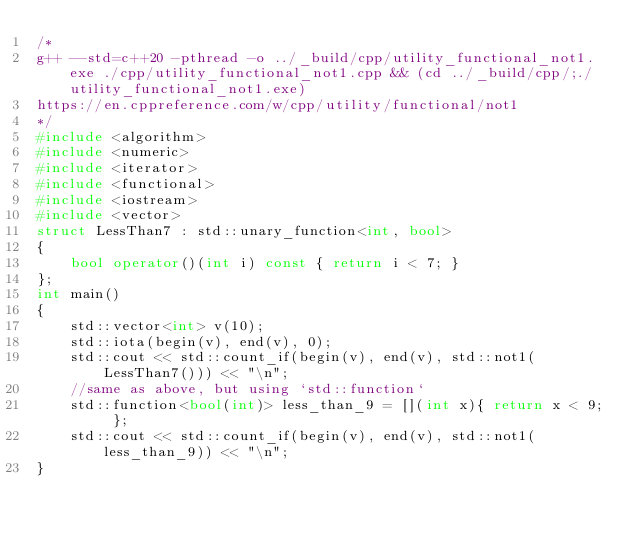<code> <loc_0><loc_0><loc_500><loc_500><_C++_>/*
g++ --std=c++20 -pthread -o ../_build/cpp/utility_functional_not1.exe ./cpp/utility_functional_not1.cpp && (cd ../_build/cpp/;./utility_functional_not1.exe)
https://en.cppreference.com/w/cpp/utility/functional/not1
*/
#include <algorithm>
#include <numeric>
#include <iterator>
#include <functional>
#include <iostream>
#include <vector>
struct LessThan7 : std::unary_function<int, bool>
{
    bool operator()(int i) const { return i < 7; }
};
int main()
{
    std::vector<int> v(10);
    std::iota(begin(v), end(v), 0);
    std::cout << std::count_if(begin(v), end(v), std::not1(LessThan7())) << "\n";
    //same as above, but using `std::function`
    std::function<bool(int)> less_than_9 = [](int x){ return x < 9; };
    std::cout << std::count_if(begin(v), end(v), std::not1(less_than_9)) << "\n";
}

</code> 